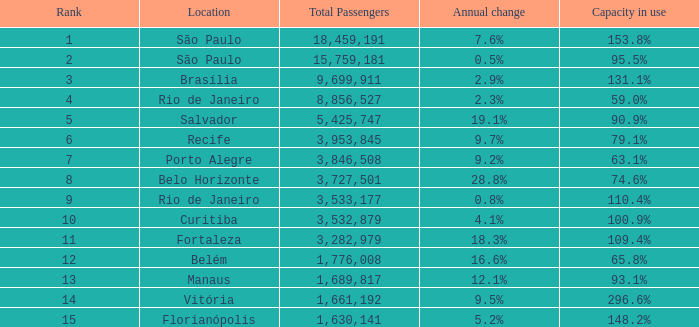With an annual growth of 28.8% and a rank lower than 8, what is the complete number of passengers? 0.0. 